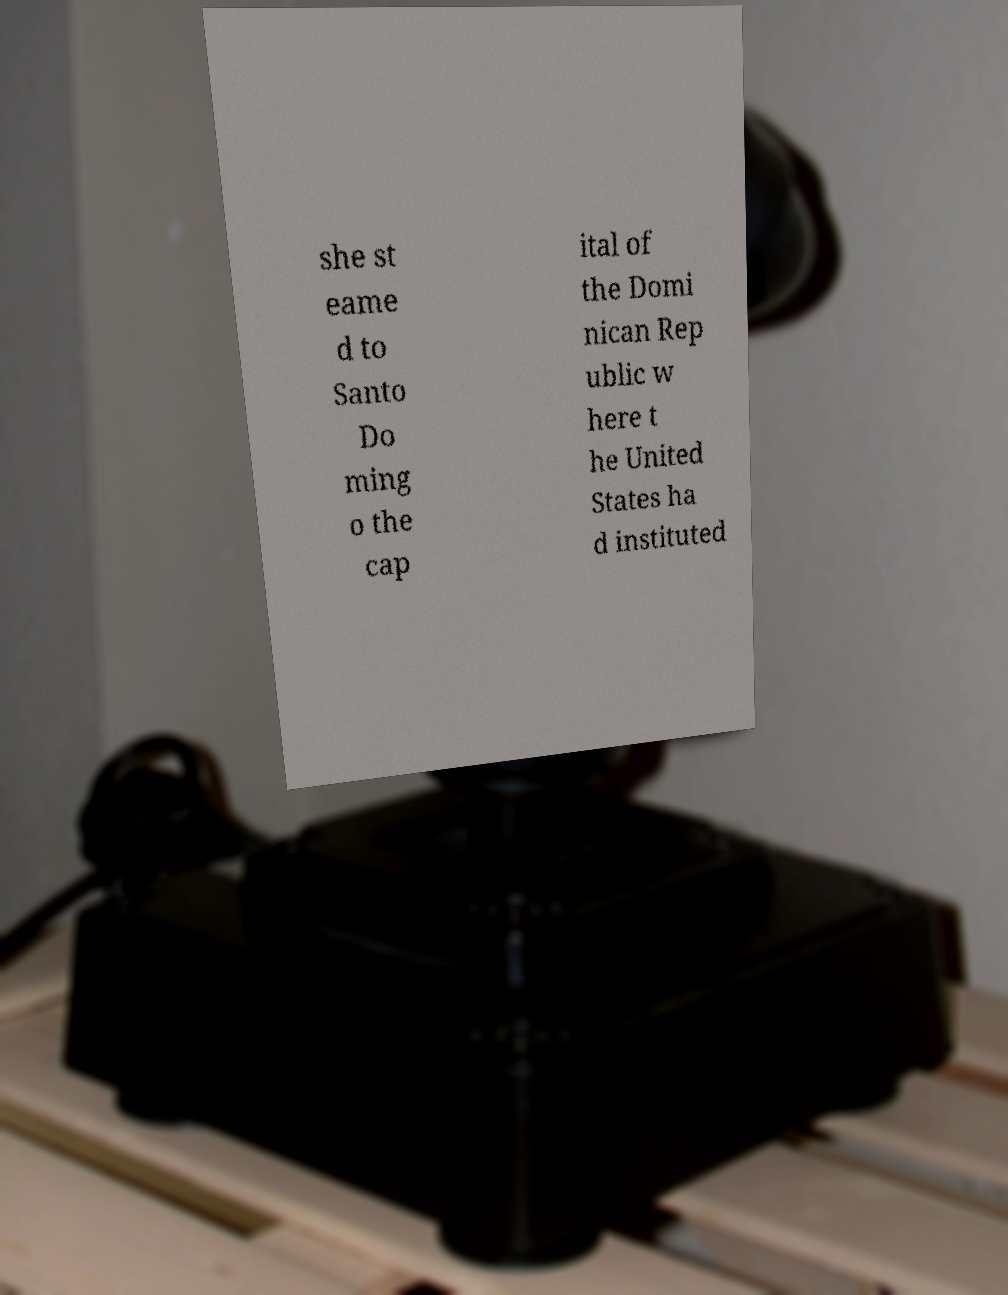Could you assist in decoding the text presented in this image and type it out clearly? she st eame d to Santo Do ming o the cap ital of the Domi nican Rep ublic w here t he United States ha d instituted 